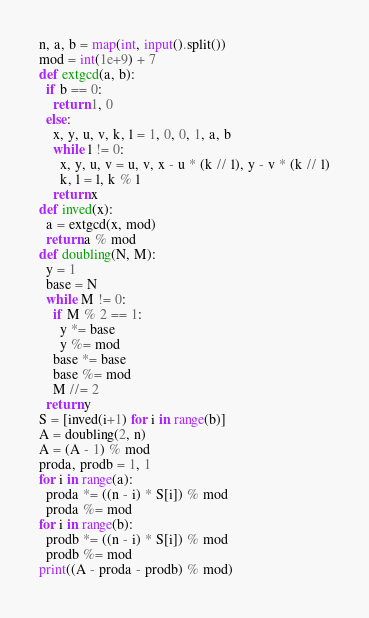<code> <loc_0><loc_0><loc_500><loc_500><_Python_>n, a, b = map(int, input().split())
mod = int(1e+9) + 7
def extgcd(a, b):
  if b == 0:
    return 1, 0
  else:
    x, y, u, v, k, l = 1, 0, 0, 1, a, b
    while l != 0:
      x, y, u, v = u, v, x - u * (k // l), y - v * (k // l)
      k, l = l, k % l
    return x
def inved(x):
  a = extgcd(x, mod)
  return a % mod
def doubling(N, M):
  y = 1
  base = N
  while M != 0:
    if M % 2 == 1:
      y *= base
      y %= mod
    base *= base
    base %= mod
    M //= 2
  return y
S = [inved(i+1) for i in range(b)]
A = doubling(2, n)
A = (A - 1) % mod
proda, prodb = 1, 1
for i in range(a):
  proda *= ((n - i) * S[i]) % mod
  proda %= mod
for i in range(b):
  prodb *= ((n - i) * S[i]) % mod
  prodb %= mod
print((A - proda - prodb) % mod)</code> 